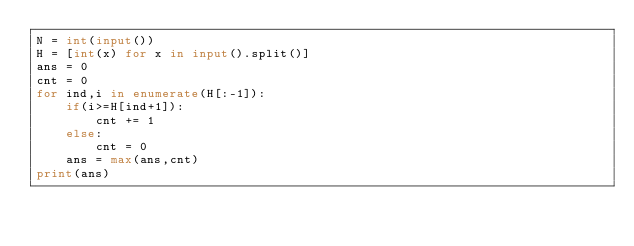Convert code to text. <code><loc_0><loc_0><loc_500><loc_500><_Python_>N = int(input())
H = [int(x) for x in input().split()]
ans = 0
cnt = 0
for ind,i in enumerate(H[:-1]):
    if(i>=H[ind+1]):
        cnt += 1
    else:
        cnt = 0
    ans = max(ans,cnt)
print(ans)</code> 